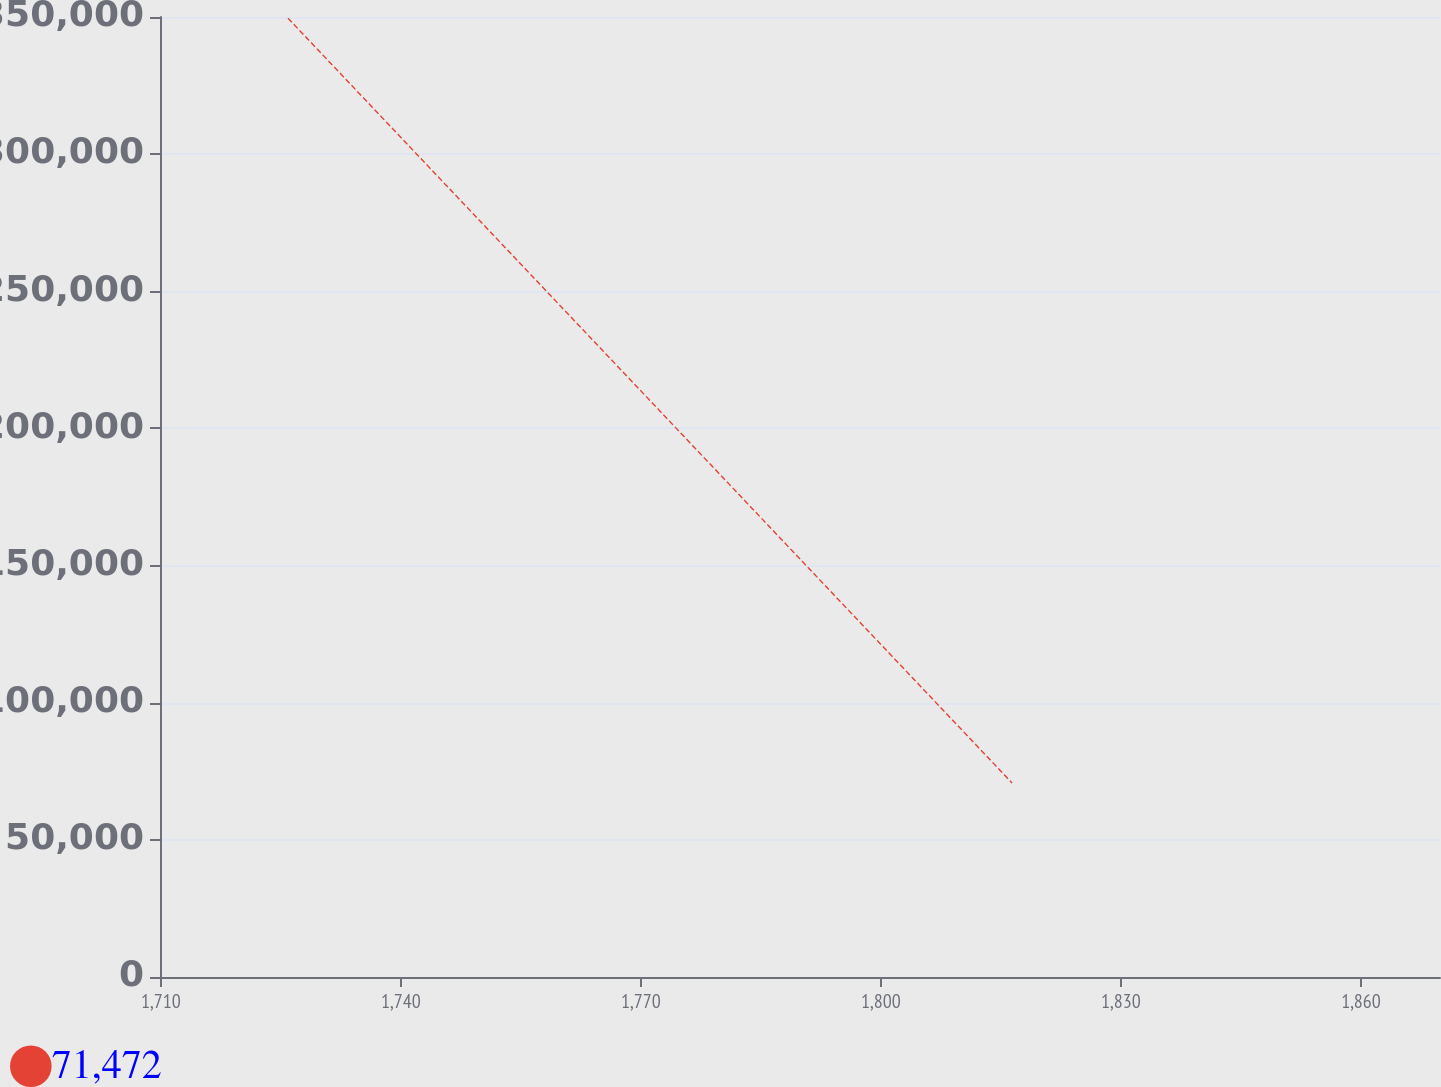Convert chart to OTSL. <chart><loc_0><loc_0><loc_500><loc_500><line_chart><ecel><fcel>71,472<nl><fcel>1725.89<fcel>349563<nl><fcel>1816.38<fcel>70752<nl><fcel>1885.87<fcel>306746<nl></chart> 